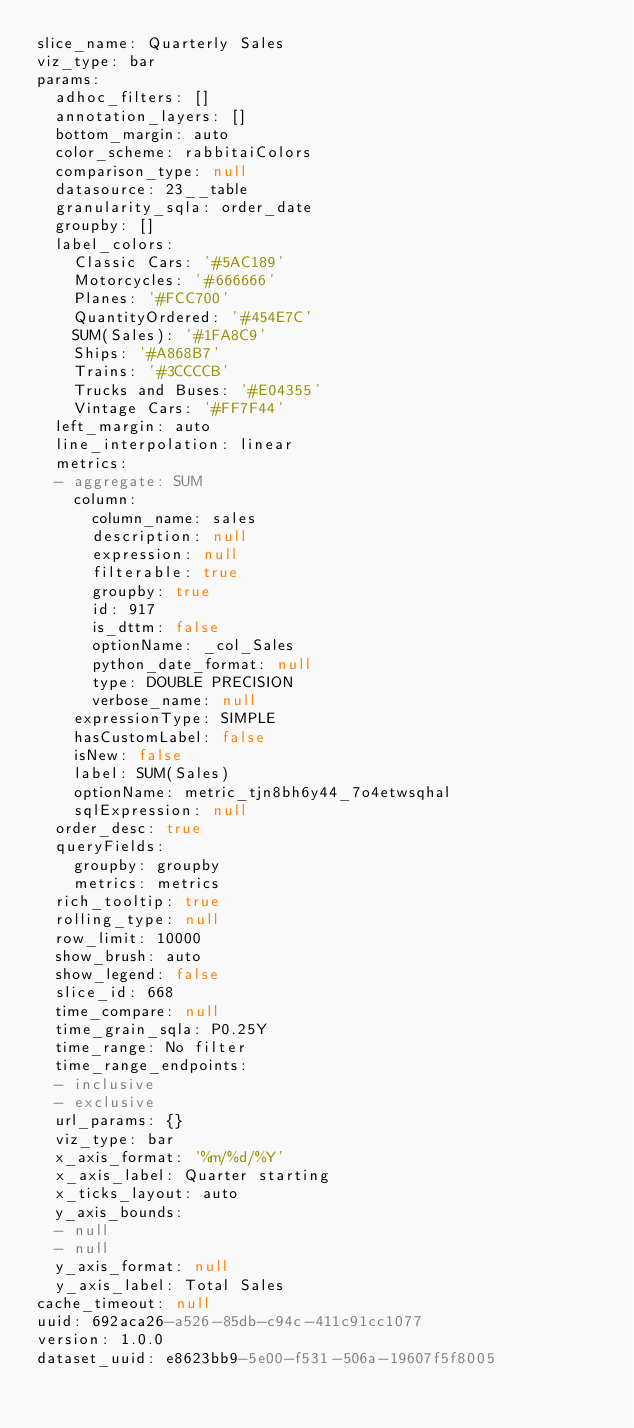Convert code to text. <code><loc_0><loc_0><loc_500><loc_500><_YAML_>slice_name: Quarterly Sales
viz_type: bar
params:
  adhoc_filters: []
  annotation_layers: []
  bottom_margin: auto
  color_scheme: rabbitaiColors
  comparison_type: null
  datasource: 23__table
  granularity_sqla: order_date
  groupby: []
  label_colors:
    Classic Cars: '#5AC189'
    Motorcycles: '#666666'
    Planes: '#FCC700'
    QuantityOrdered: '#454E7C'
    SUM(Sales): '#1FA8C9'
    Ships: '#A868B7'
    Trains: '#3CCCCB'
    Trucks and Buses: '#E04355'
    Vintage Cars: '#FF7F44'
  left_margin: auto
  line_interpolation: linear
  metrics:
  - aggregate: SUM
    column:
      column_name: sales
      description: null
      expression: null
      filterable: true
      groupby: true
      id: 917
      is_dttm: false
      optionName: _col_Sales
      python_date_format: null
      type: DOUBLE PRECISION
      verbose_name: null
    expressionType: SIMPLE
    hasCustomLabel: false
    isNew: false
    label: SUM(Sales)
    optionName: metric_tjn8bh6y44_7o4etwsqhal
    sqlExpression: null
  order_desc: true
  queryFields:
    groupby: groupby
    metrics: metrics
  rich_tooltip: true
  rolling_type: null
  row_limit: 10000
  show_brush: auto
  show_legend: false
  slice_id: 668
  time_compare: null
  time_grain_sqla: P0.25Y
  time_range: No filter
  time_range_endpoints:
  - inclusive
  - exclusive
  url_params: {}
  viz_type: bar
  x_axis_format: '%m/%d/%Y'
  x_axis_label: Quarter starting
  x_ticks_layout: auto
  y_axis_bounds:
  - null
  - null
  y_axis_format: null
  y_axis_label: Total Sales
cache_timeout: null
uuid: 692aca26-a526-85db-c94c-411c91cc1077
version: 1.0.0
dataset_uuid: e8623bb9-5e00-f531-506a-19607f5f8005
</code> 